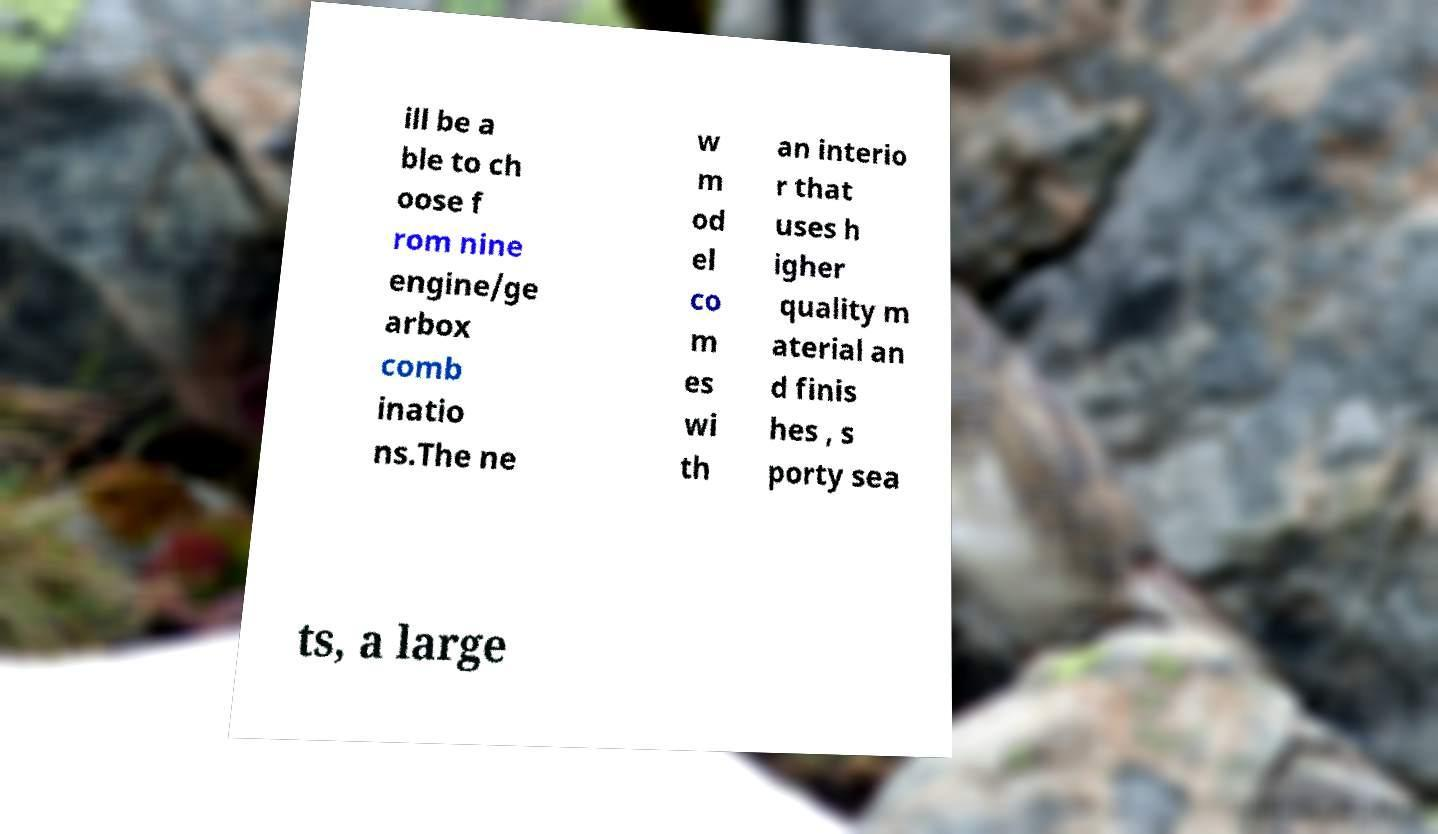Could you extract and type out the text from this image? ill be a ble to ch oose f rom nine engine/ge arbox comb inatio ns.The ne w m od el co m es wi th an interio r that uses h igher quality m aterial an d finis hes , s porty sea ts, a large 